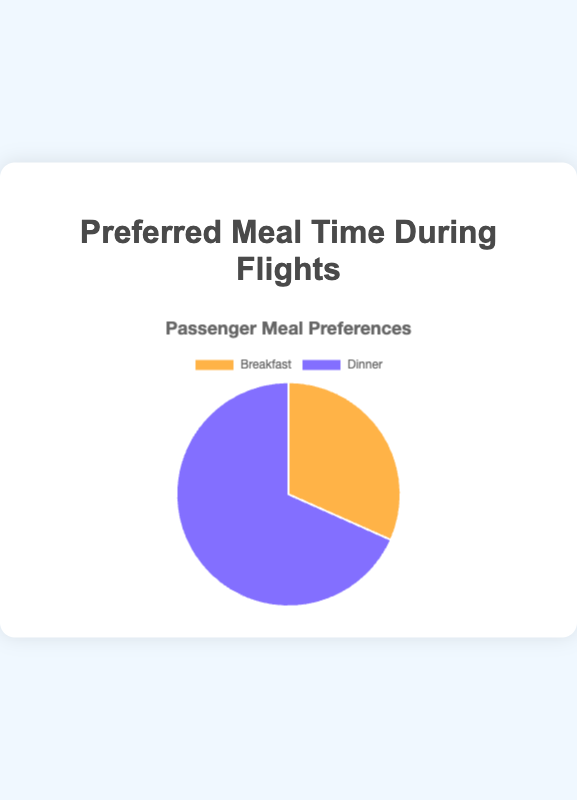What's the total number of passengers preferring Breakfast or Dinner? The chart shows the total number of passengers for Breakfast and Dinner preferences as 950 and 2050 respectively. Adding these numbers gives the total: 950 + 2050 = 3000 passengers.
Answer: 3000 Which meal preference has more passengers, Breakfast or Dinner? The chart shows 950 passengers preferred Breakfast while 2050 passengers preferred Dinner. Comparing these values, Dinner has more passengers.
Answer: Dinner By what percentage do Dinner preferences exceed Breakfast preferences? The chart data shows 2050 passengers prefer Dinner and 950 prefer Breakfast. To find the percentage increase: ((2050 - 950) / 950) * 100 = 115.79%.
Answer: 115.79% What is the ratio of Dinner to Breakfast preferences? The chart shows Dinner preferences as 2050 and Breakfast preferences as 950. The ratio is calculated as 2050 / 950, which simplifies approximately to 2.16.
Answer: 2.16 What is the proportion of Breakfast preferences out of the total preferences? The chart indicates 950 out of 3000 total passengers prefer Breakfast. The proportion is 950 / 3000 = 0.3167 or 31.67%.
Answer: 31.67% What is the difference in the number of passengers preferring Dinner compared to Breakfast? The chart shows Dinner is preferred by 2050 passengers and Breakfast by 950. The difference is 2050 - 950 = 1100 passengers.
Answer: 1100 Among Breakfast and Dinner preferences, which has the smallest proportion of passengers? By looking at the pie chart slices, Breakfast has a smaller slice compared to Dinner, indicating it has the smallest proportion.
Answer: Breakfast How much larger is the Dinner preference slice compared to the Breakfast slice visually? The Dinner slice is significantly larger than the Breakfast slice. Dinner has more than double the number of passengers compared to Breakfast, making it visually much larger.
Answer: Significantly larger What percentage of total passengers prefer Dinner? The chart shows 2050 out of 3000 total passengers prefer Dinner. The percentage is (2050 / 3000) * 100 = 68.33%.
Answer: 68.33% If the number of Breakfast preferences increased by 50%, what would be the new total for Breakfast preferences? The current Breakfast preference is 950. Adding 50% more: 950 * 1.5 = 1425 passengers.
Answer: 1425 